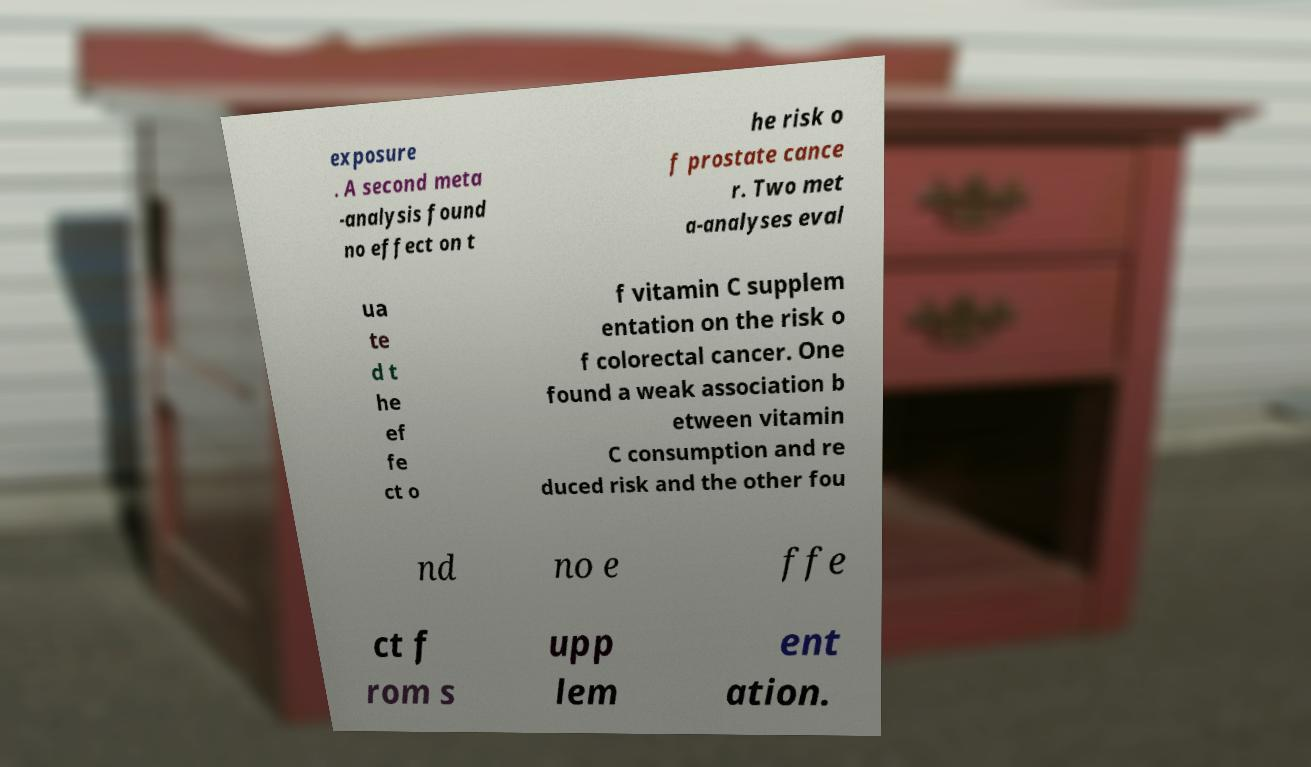Can you read and provide the text displayed in the image?This photo seems to have some interesting text. Can you extract and type it out for me? exposure . A second meta -analysis found no effect on t he risk o f prostate cance r. Two met a-analyses eval ua te d t he ef fe ct o f vitamin C supplem entation on the risk o f colorectal cancer. One found a weak association b etween vitamin C consumption and re duced risk and the other fou nd no e ffe ct f rom s upp lem ent ation. 